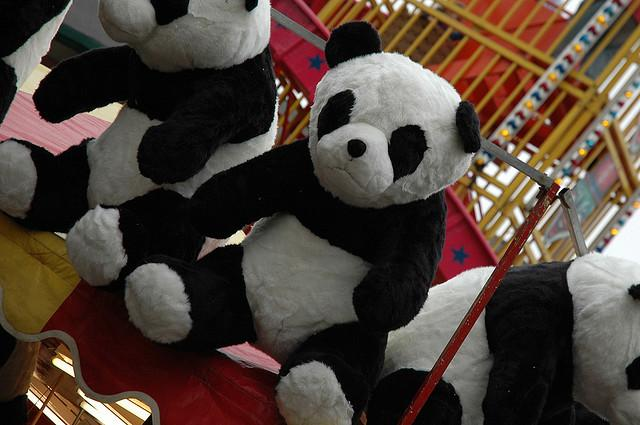This animal is a symbol of what nation?

Choices:
A) ukraine
B) china
C) scotland
D) tanzania china 